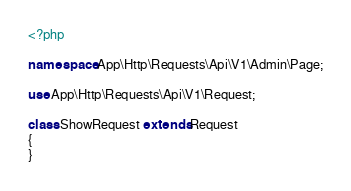<code> <loc_0><loc_0><loc_500><loc_500><_PHP_><?php

namespace App\Http\Requests\Api\V1\Admin\Page;

use App\Http\Requests\Api\V1\Request;

class ShowRequest extends Request
{
}
</code> 